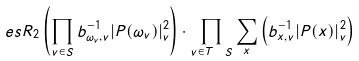<formula> <loc_0><loc_0><loc_500><loc_500>\ e s R _ { 2 } \left ( \prod _ { v \in S } b _ { \omega _ { v } , v } ^ { - 1 } | P ( \omega _ { v } ) | _ { v } ^ { 2 } \right ) \cdot \prod _ { v \in T \ S } \sum _ { x } \left ( b _ { x , v } ^ { - 1 } | P ( x ) | ^ { 2 } _ { v } \right )</formula> 